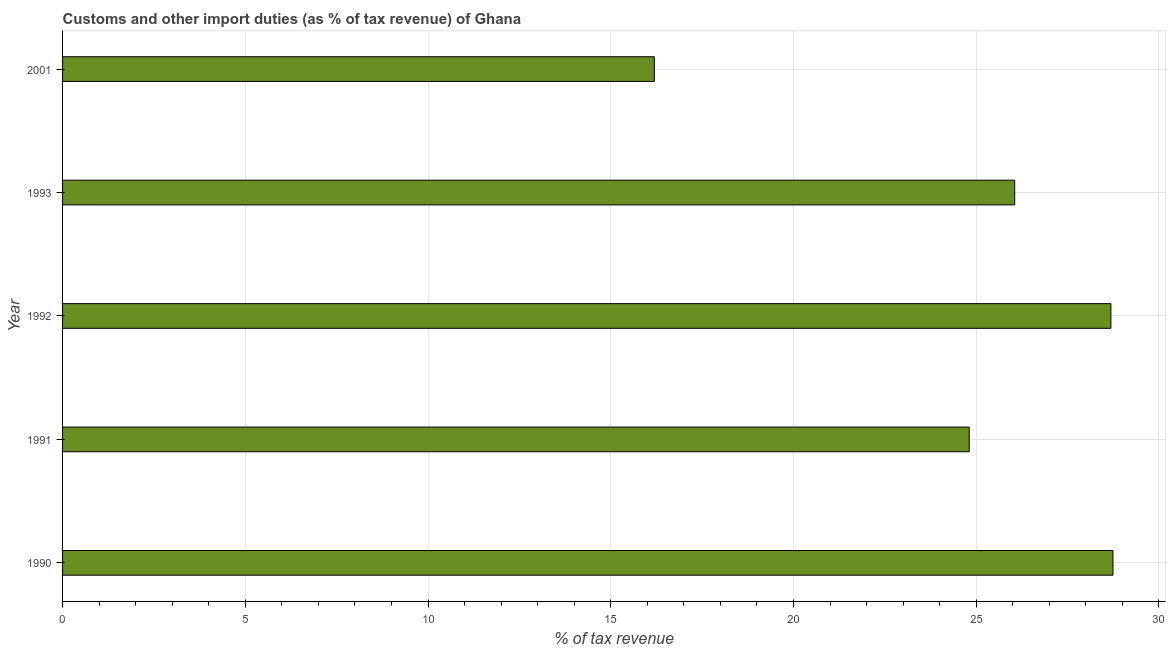Does the graph contain any zero values?
Your answer should be compact. No. What is the title of the graph?
Offer a very short reply. Customs and other import duties (as % of tax revenue) of Ghana. What is the label or title of the X-axis?
Your answer should be very brief. % of tax revenue. What is the customs and other import duties in 1991?
Your answer should be compact. 24.81. Across all years, what is the maximum customs and other import duties?
Make the answer very short. 28.74. Across all years, what is the minimum customs and other import duties?
Offer a terse response. 16.19. In which year was the customs and other import duties maximum?
Your answer should be very brief. 1990. In which year was the customs and other import duties minimum?
Make the answer very short. 2001. What is the sum of the customs and other import duties?
Your answer should be compact. 124.48. What is the difference between the customs and other import duties in 1990 and 1992?
Your answer should be very brief. 0.06. What is the average customs and other import duties per year?
Your response must be concise. 24.9. What is the median customs and other import duties?
Your answer should be compact. 26.05. In how many years, is the customs and other import duties greater than 26 %?
Provide a succinct answer. 3. What is the ratio of the customs and other import duties in 1991 to that in 1992?
Your response must be concise. 0.86. What is the difference between the highest and the second highest customs and other import duties?
Offer a very short reply. 0.06. Is the sum of the customs and other import duties in 1992 and 2001 greater than the maximum customs and other import duties across all years?
Offer a terse response. Yes. What is the difference between the highest and the lowest customs and other import duties?
Your answer should be very brief. 12.55. Are all the bars in the graph horizontal?
Ensure brevity in your answer.  Yes. How many years are there in the graph?
Your response must be concise. 5. What is the % of tax revenue of 1990?
Offer a very short reply. 28.74. What is the % of tax revenue in 1991?
Your answer should be very brief. 24.81. What is the % of tax revenue of 1992?
Your response must be concise. 28.69. What is the % of tax revenue of 1993?
Make the answer very short. 26.05. What is the % of tax revenue in 2001?
Keep it short and to the point. 16.19. What is the difference between the % of tax revenue in 1990 and 1991?
Your answer should be very brief. 3.93. What is the difference between the % of tax revenue in 1990 and 1992?
Keep it short and to the point. 0.06. What is the difference between the % of tax revenue in 1990 and 1993?
Ensure brevity in your answer.  2.69. What is the difference between the % of tax revenue in 1990 and 2001?
Make the answer very short. 12.55. What is the difference between the % of tax revenue in 1991 and 1992?
Make the answer very short. -3.88. What is the difference between the % of tax revenue in 1991 and 1993?
Provide a short and direct response. -1.24. What is the difference between the % of tax revenue in 1991 and 2001?
Provide a succinct answer. 8.62. What is the difference between the % of tax revenue in 1992 and 1993?
Give a very brief answer. 2.63. What is the difference between the % of tax revenue in 1992 and 2001?
Your answer should be compact. 12.49. What is the difference between the % of tax revenue in 1993 and 2001?
Offer a terse response. 9.86. What is the ratio of the % of tax revenue in 1990 to that in 1991?
Your answer should be compact. 1.16. What is the ratio of the % of tax revenue in 1990 to that in 1993?
Ensure brevity in your answer.  1.1. What is the ratio of the % of tax revenue in 1990 to that in 2001?
Provide a short and direct response. 1.77. What is the ratio of the % of tax revenue in 1991 to that in 1992?
Your response must be concise. 0.86. What is the ratio of the % of tax revenue in 1991 to that in 1993?
Give a very brief answer. 0.95. What is the ratio of the % of tax revenue in 1991 to that in 2001?
Your answer should be compact. 1.53. What is the ratio of the % of tax revenue in 1992 to that in 1993?
Give a very brief answer. 1.1. What is the ratio of the % of tax revenue in 1992 to that in 2001?
Give a very brief answer. 1.77. What is the ratio of the % of tax revenue in 1993 to that in 2001?
Keep it short and to the point. 1.61. 